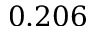Convert formula to latex. <formula><loc_0><loc_0><loc_500><loc_500>0 . 2 0 6</formula> 